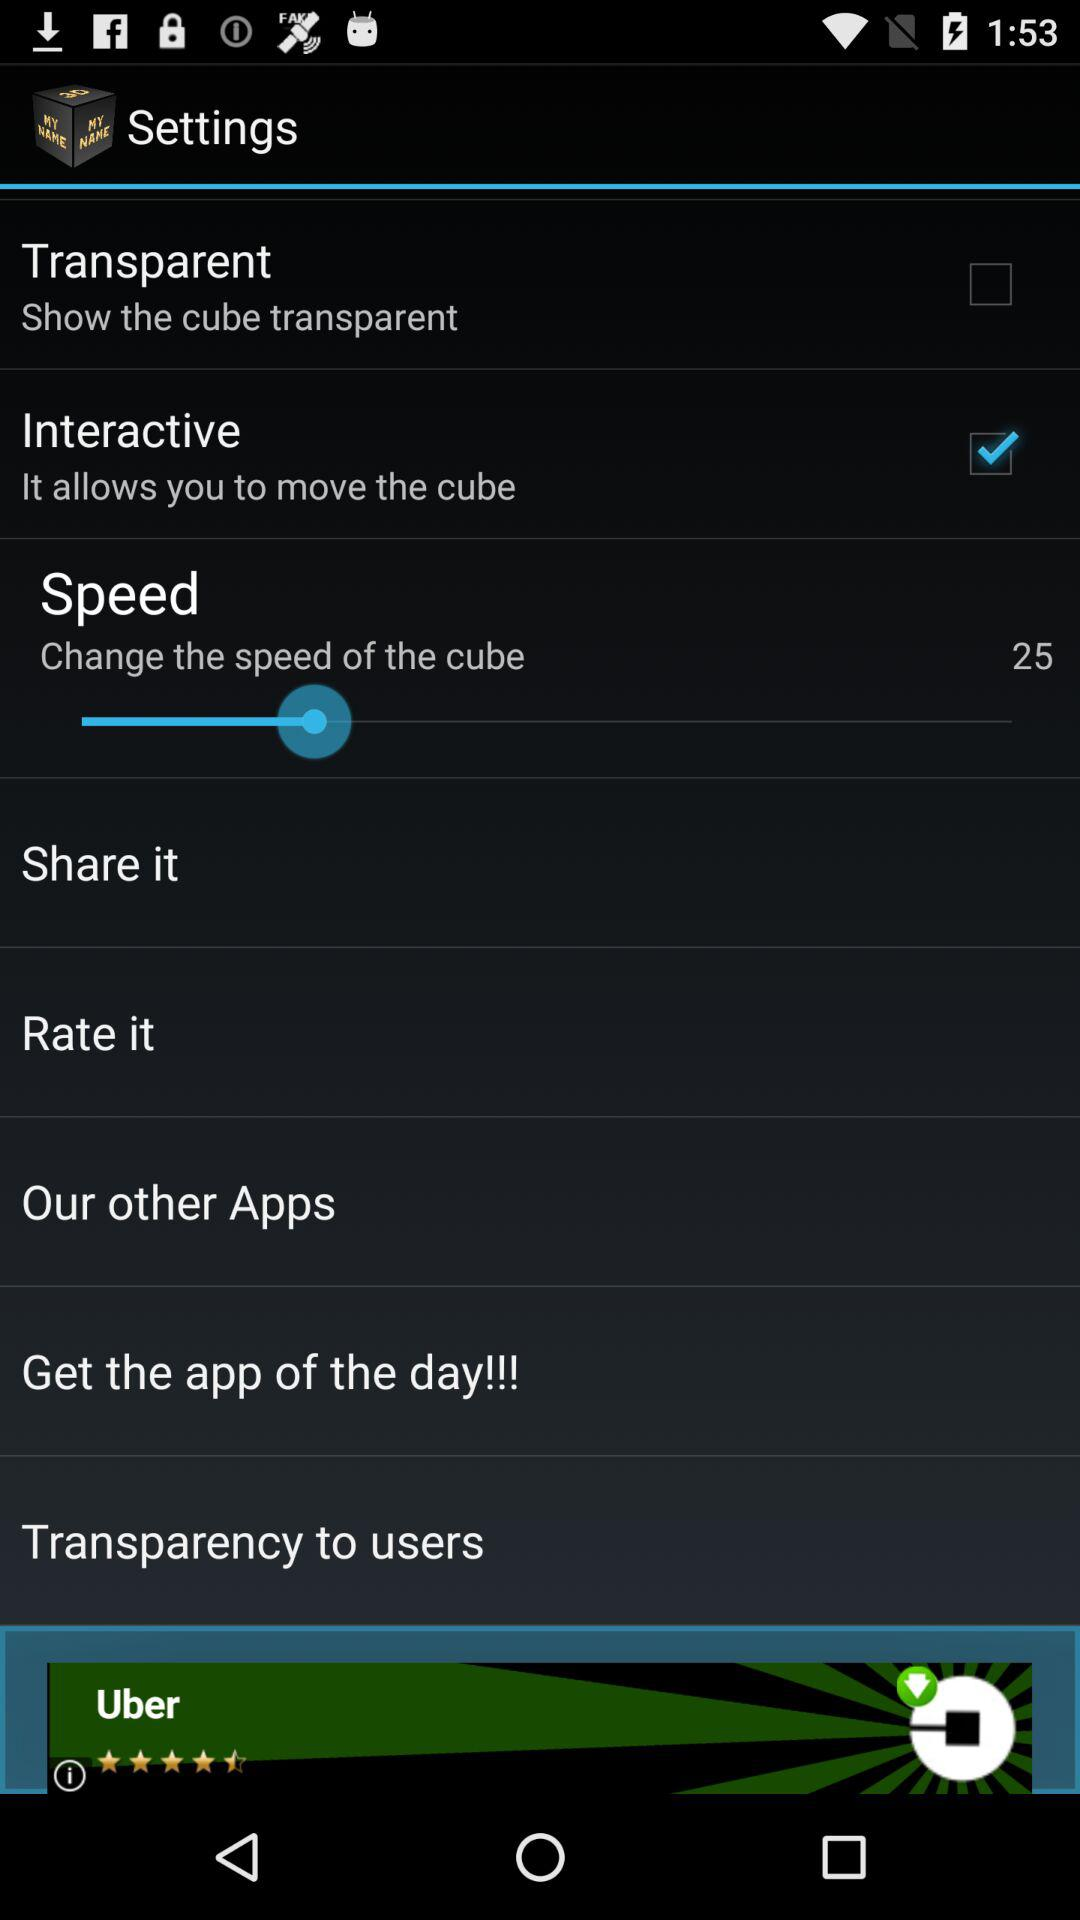Which is the checked option? The checked option is "Interactive". 